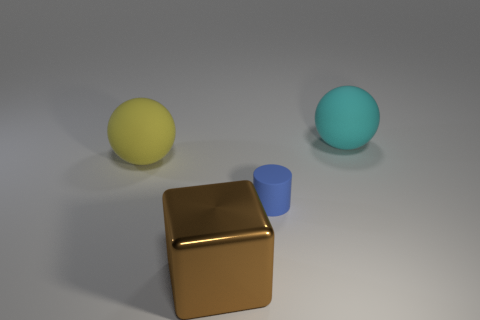There is another object that is the same shape as the big cyan rubber thing; what is its size?
Your answer should be very brief. Large. Is the number of large spheres greater than the number of blue rubber objects?
Provide a succinct answer. Yes. Is the shape of the large brown thing the same as the tiny rubber object?
Provide a short and direct response. No. What is the sphere on the right side of the matte sphere left of the large metallic object made of?
Give a very brief answer. Rubber. Is the size of the metallic thing the same as the yellow sphere?
Keep it short and to the point. Yes. There is a matte sphere right of the tiny thing; are there any large brown metal things in front of it?
Provide a short and direct response. Yes. There is a cyan thing behind the metallic cube; what shape is it?
Offer a terse response. Sphere. There is a sphere on the left side of the big rubber thing that is on the right side of the metal cube; what number of large matte objects are on the right side of it?
Make the answer very short. 1. There is a blue rubber cylinder; does it have the same size as the rubber ball that is on the right side of the brown metallic cube?
Offer a very short reply. No. There is a matte ball on the left side of the large rubber object that is right of the small blue rubber object; what size is it?
Make the answer very short. Large. 